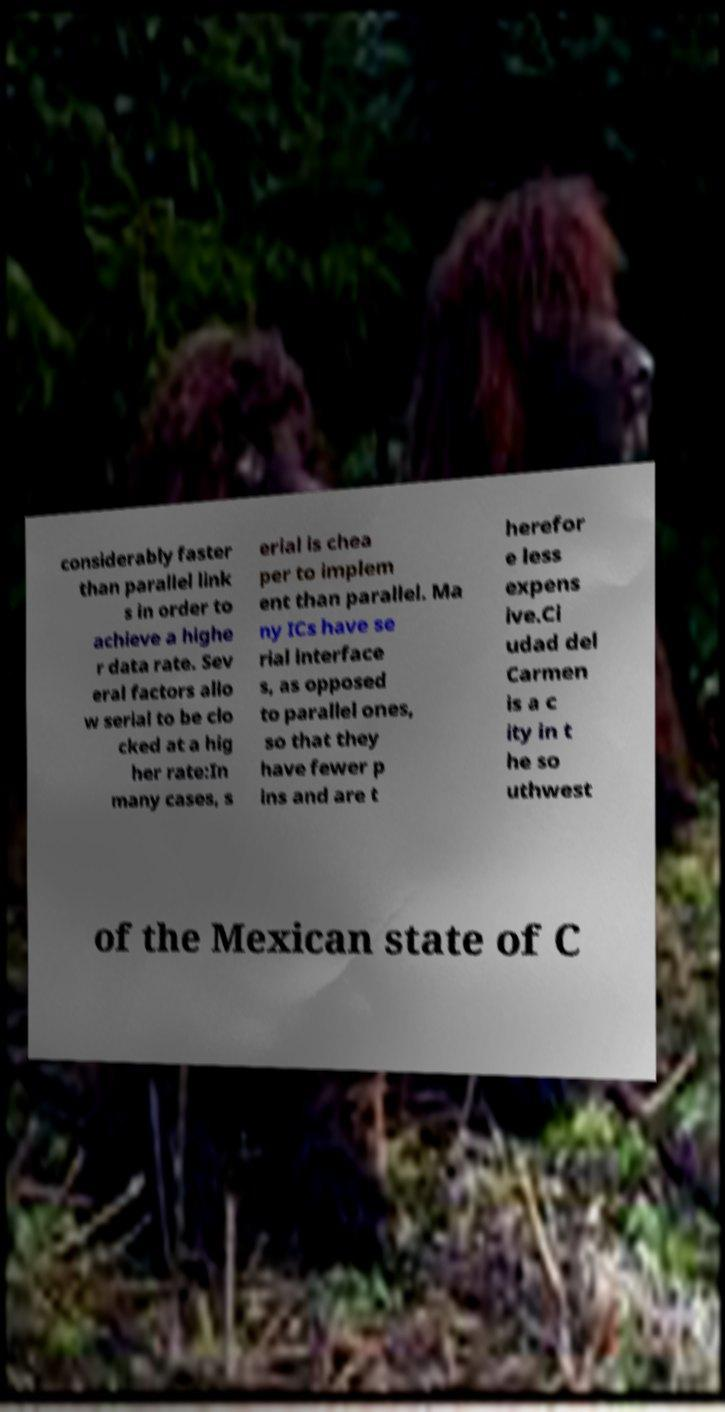Can you read and provide the text displayed in the image?This photo seems to have some interesting text. Can you extract and type it out for me? considerably faster than parallel link s in order to achieve a highe r data rate. Sev eral factors allo w serial to be clo cked at a hig her rate:In many cases, s erial is chea per to implem ent than parallel. Ma ny ICs have se rial interface s, as opposed to parallel ones, so that they have fewer p ins and are t herefor e less expens ive.Ci udad del Carmen is a c ity in t he so uthwest of the Mexican state of C 